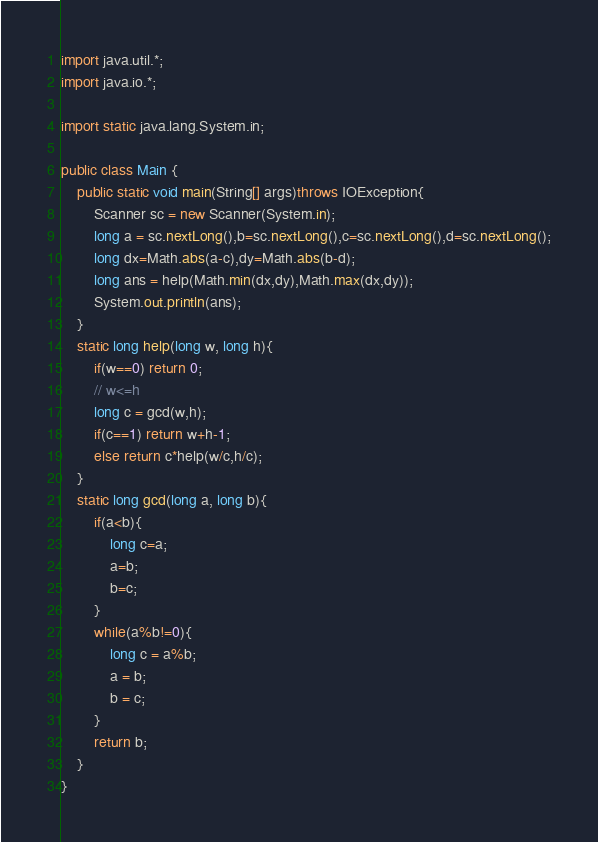<code> <loc_0><loc_0><loc_500><loc_500><_Java_>import java.util.*;
import java.io.*;

import static java.lang.System.in;

public class Main {
    public static void main(String[] args)throws IOException{
        Scanner sc = new Scanner(System.in);
        long a = sc.nextLong(),b=sc.nextLong(),c=sc.nextLong(),d=sc.nextLong();
        long dx=Math.abs(a-c),dy=Math.abs(b-d);
        long ans = help(Math.min(dx,dy),Math.max(dx,dy));
        System.out.println(ans);
    }
    static long help(long w, long h){
        if(w==0) return 0;
        // w<=h
        long c = gcd(w,h);
        if(c==1) return w+h-1;
        else return c*help(w/c,h/c);
    }
    static long gcd(long a, long b){
        if(a<b){
            long c=a;
            a=b;
            b=c;
        }
        while(a%b!=0){
            long c = a%b;
            a = b;
            b = c;
        }
        return b;
    }
}
</code> 